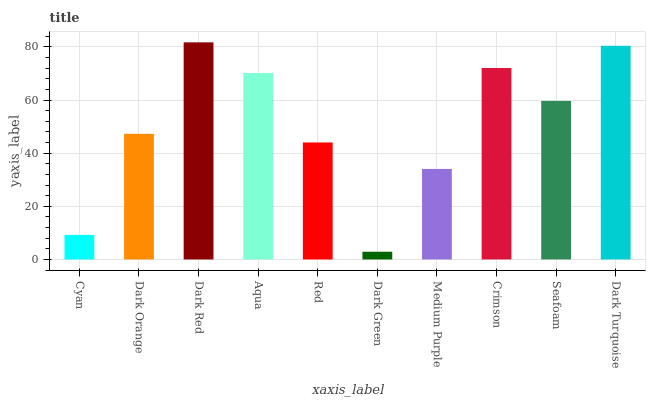Is Dark Orange the minimum?
Answer yes or no. No. Is Dark Orange the maximum?
Answer yes or no. No. Is Dark Orange greater than Cyan?
Answer yes or no. Yes. Is Cyan less than Dark Orange?
Answer yes or no. Yes. Is Cyan greater than Dark Orange?
Answer yes or no. No. Is Dark Orange less than Cyan?
Answer yes or no. No. Is Seafoam the high median?
Answer yes or no. Yes. Is Dark Orange the low median?
Answer yes or no. Yes. Is Cyan the high median?
Answer yes or no. No. Is Dark Turquoise the low median?
Answer yes or no. No. 